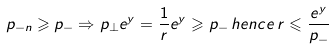Convert formula to latex. <formula><loc_0><loc_0><loc_500><loc_500>p _ { - n } \geqslant p _ { - } \Rightarrow p _ { \perp } e ^ { y } = \frac { 1 } { r } e ^ { y } \geqslant p _ { - } \, h e n c e \, r \leqslant \frac { e ^ { y } } { p _ { - } }</formula> 